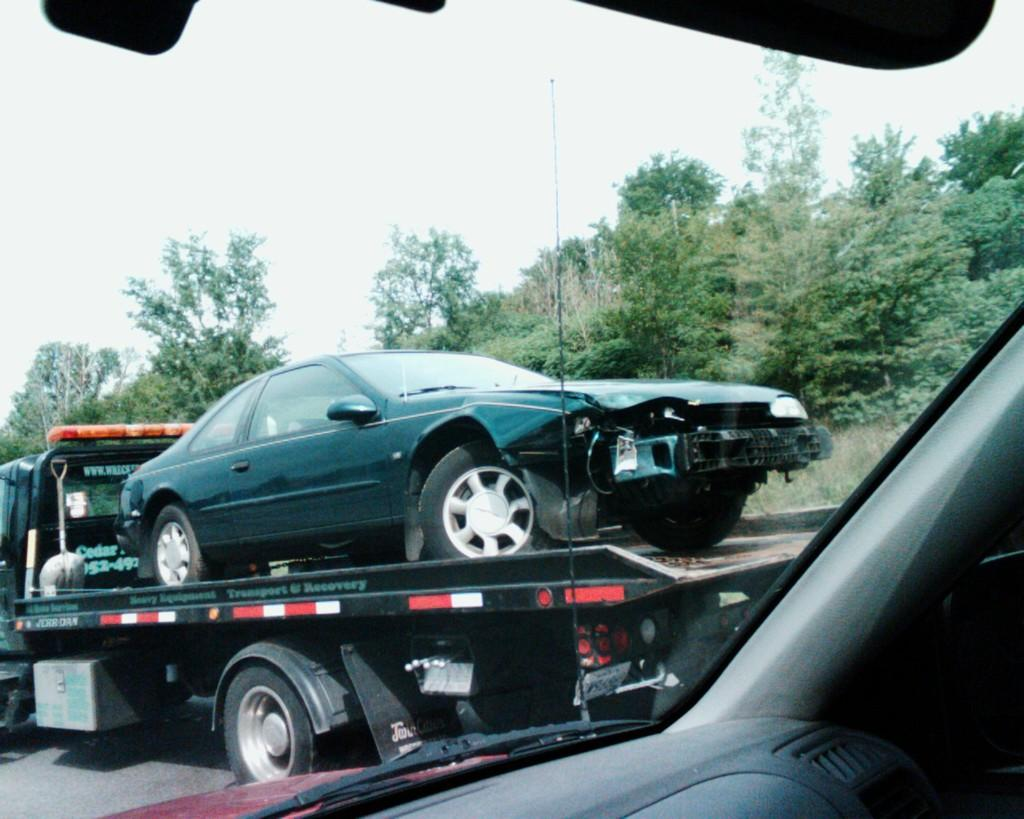What is the black object in the front of the image? There is an object in the front of the image, which is black in color. What is the purpose of the wiper in the image? The wiper is used to clean the windshield of the car. What is located behind the wiper in the image? There is a car behind the wiper in the image. What type of vegetation can be seen in the image? There are trees visible in the image. How many fish are swimming in the car's engine in the image? There are no fish present in the image, and the car's engine is not visible. 